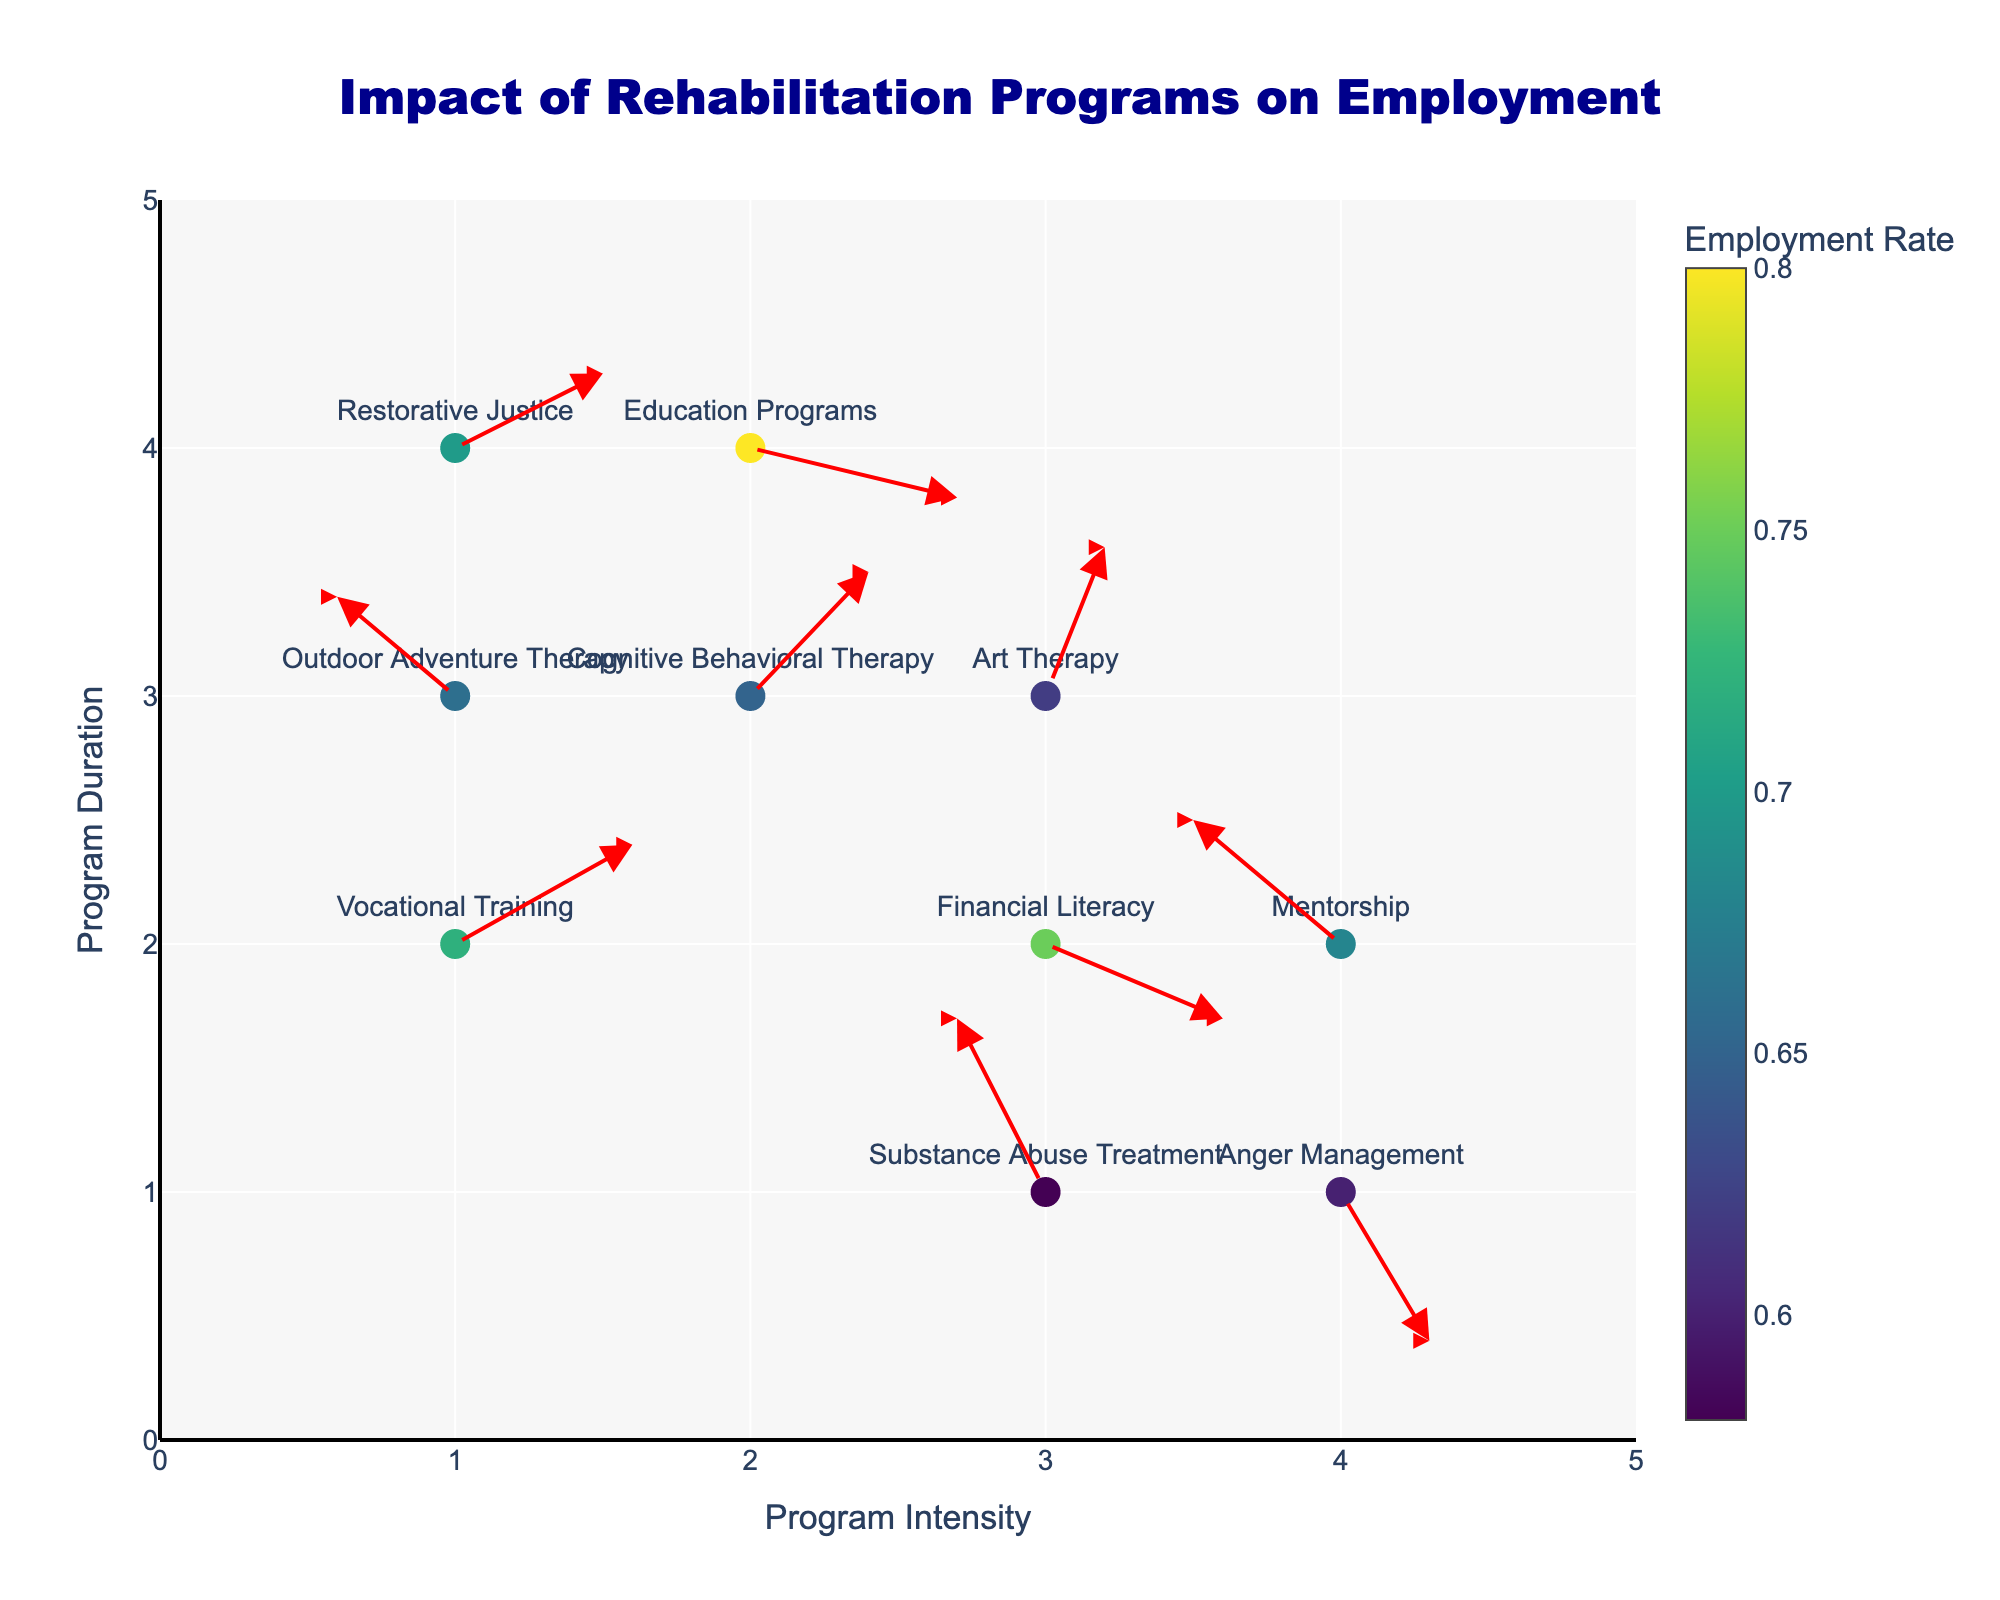What's the title of the figure? The title is prominently displayed at the top of the figure in large, bold text. The title reads "Impact of Rehabilitation Programs on Employment."
Answer: Impact of Rehabilitation Programs on Employment How many program types are depicted in the plot? Each program type is represented by a labeled marker. Counting these markers, there are 10 program types in total.
Answer: 10 Which program has the highest employment rate and what is it? The color bar indicates employment rates, with darker shades representing higher rates. The text label of the marker with the darkest shade shows that "Education Programs" has the highest employment rate of 0.80.
Answer: Education Programs, 0.80 What job sector is associated with "Substance Abuse Treatment"? Hovering over the marker for "Substance Abuse Treatment" reveals details including the job sector, which is "Hospitality".
Answer: Hospitality What is the average employment rate for the programs "Vocational Training" and "Financial Literacy"? Both programs’ employment rates can be read from the hover details and are 0.72 and 0.75 respectively. The average is calculated as (0.72 + 0.75) / 2 = 0.735.
Answer: 0.735 Which programs show a movement towards higher Y values? Arrows showing movement direction depict this. Arrows from "Cognitive Behavioral Therapy", "Substance Abuse Treatment", "Art Therapy", "Restorative Justice", and "Outdoor Adventure Therapy" move upwards indicating an increase in Y value.
Answer: Cognitive Behavioral Therapy, Substance Abuse Treatment, Art Therapy, Restorative Justice, Outdoor Adventure Therapy Is the direction of the arrow for "Anger Management" going upward or downward? Examining the arrow direction for the "Anger Management" marker shows it pointing downward, indicating a negative change in Y value.
Answer: Downward Which program type shows the greatest change in both X and Y directions combined? By calculating the magnitude of change √(U^2 + V^2) for each program, "Substance Abuse Treatment" shows the largest combined change with a U of -0.3 and V of 0.7, totaling √((-0.3)^2 + 0.7^2) ≈ 0.76.
Answer: Substance Abuse Treatment Compare the employment rates of "Mentorship" and "Art Therapy". Which is higher? Employment rates marked on both "Mentorship" and "Art Therapy" show 0.68 and 0.62, respectively. "Mentorship" has the higher rate.
Answer: Mentorship What is the location (X, Y) of the "Technology" job sector in this plot? Hovering over the "Education Programs" marker, which is associated with the "Technology" job sector, shows its coordinates as (2, 4).
Answer: (2, 4) 